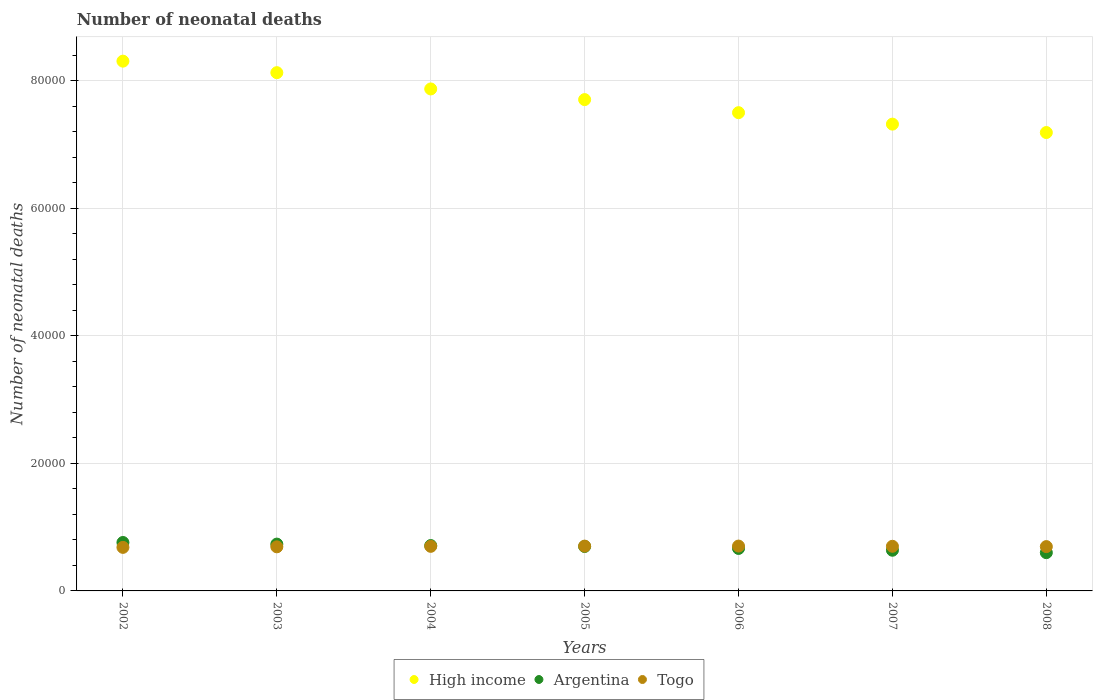How many different coloured dotlines are there?
Provide a succinct answer. 3. What is the number of neonatal deaths in in Togo in 2007?
Offer a very short reply. 6999. Across all years, what is the maximum number of neonatal deaths in in Togo?
Your response must be concise. 7032. Across all years, what is the minimum number of neonatal deaths in in Togo?
Your answer should be compact. 6828. What is the total number of neonatal deaths in in Argentina in the graph?
Give a very brief answer. 4.81e+04. What is the difference between the number of neonatal deaths in in Argentina in 2003 and that in 2007?
Offer a very short reply. 962. What is the difference between the number of neonatal deaths in in Togo in 2006 and the number of neonatal deaths in in High income in 2004?
Keep it short and to the point. -7.17e+04. What is the average number of neonatal deaths in in Togo per year?
Provide a short and direct response. 6962.57. In the year 2005, what is the difference between the number of neonatal deaths in in Argentina and number of neonatal deaths in in Togo?
Keep it short and to the point. -61. What is the ratio of the number of neonatal deaths in in High income in 2002 to that in 2006?
Provide a short and direct response. 1.11. What is the difference between the highest and the second highest number of neonatal deaths in in High income?
Your answer should be very brief. 1805. What is the difference between the highest and the lowest number of neonatal deaths in in Togo?
Ensure brevity in your answer.  204. In how many years, is the number of neonatal deaths in in Togo greater than the average number of neonatal deaths in in Togo taken over all years?
Provide a succinct answer. 4. Is it the case that in every year, the sum of the number of neonatal deaths in in Togo and number of neonatal deaths in in High income  is greater than the number of neonatal deaths in in Argentina?
Your response must be concise. Yes. Does the number of neonatal deaths in in Togo monotonically increase over the years?
Your answer should be very brief. No. How many dotlines are there?
Provide a short and direct response. 3. Does the graph contain grids?
Give a very brief answer. Yes. How many legend labels are there?
Provide a succinct answer. 3. What is the title of the graph?
Ensure brevity in your answer.  Number of neonatal deaths. Does "East Asia (all income levels)" appear as one of the legend labels in the graph?
Provide a short and direct response. No. What is the label or title of the Y-axis?
Your response must be concise. Number of neonatal deaths. What is the Number of neonatal deaths in High income in 2002?
Your answer should be very brief. 8.31e+04. What is the Number of neonatal deaths in Argentina in 2002?
Your response must be concise. 7595. What is the Number of neonatal deaths in Togo in 2002?
Provide a short and direct response. 6828. What is the Number of neonatal deaths in High income in 2003?
Offer a very short reply. 8.13e+04. What is the Number of neonatal deaths of Argentina in 2003?
Make the answer very short. 7341. What is the Number of neonatal deaths in Togo in 2003?
Your response must be concise. 6914. What is the Number of neonatal deaths in High income in 2004?
Your answer should be compact. 7.87e+04. What is the Number of neonatal deaths in Argentina in 2004?
Keep it short and to the point. 7113. What is the Number of neonatal deaths in Togo in 2004?
Your answer should be compact. 6990. What is the Number of neonatal deaths in High income in 2005?
Make the answer very short. 7.70e+04. What is the Number of neonatal deaths of Argentina in 2005?
Provide a succinct answer. 6965. What is the Number of neonatal deaths in Togo in 2005?
Keep it short and to the point. 7026. What is the Number of neonatal deaths of High income in 2006?
Offer a terse response. 7.50e+04. What is the Number of neonatal deaths of Argentina in 2006?
Offer a very short reply. 6660. What is the Number of neonatal deaths in Togo in 2006?
Make the answer very short. 7032. What is the Number of neonatal deaths in High income in 2007?
Your answer should be compact. 7.32e+04. What is the Number of neonatal deaths in Argentina in 2007?
Your answer should be very brief. 6379. What is the Number of neonatal deaths of Togo in 2007?
Ensure brevity in your answer.  6999. What is the Number of neonatal deaths in High income in 2008?
Provide a short and direct response. 7.19e+04. What is the Number of neonatal deaths in Argentina in 2008?
Keep it short and to the point. 6001. What is the Number of neonatal deaths of Togo in 2008?
Your answer should be compact. 6949. Across all years, what is the maximum Number of neonatal deaths of High income?
Your answer should be very brief. 8.31e+04. Across all years, what is the maximum Number of neonatal deaths of Argentina?
Provide a succinct answer. 7595. Across all years, what is the maximum Number of neonatal deaths of Togo?
Your answer should be compact. 7032. Across all years, what is the minimum Number of neonatal deaths of High income?
Offer a terse response. 7.19e+04. Across all years, what is the minimum Number of neonatal deaths in Argentina?
Provide a succinct answer. 6001. Across all years, what is the minimum Number of neonatal deaths in Togo?
Ensure brevity in your answer.  6828. What is the total Number of neonatal deaths of High income in the graph?
Keep it short and to the point. 5.40e+05. What is the total Number of neonatal deaths of Argentina in the graph?
Your response must be concise. 4.81e+04. What is the total Number of neonatal deaths of Togo in the graph?
Provide a succinct answer. 4.87e+04. What is the difference between the Number of neonatal deaths in High income in 2002 and that in 2003?
Ensure brevity in your answer.  1805. What is the difference between the Number of neonatal deaths in Argentina in 2002 and that in 2003?
Make the answer very short. 254. What is the difference between the Number of neonatal deaths in Togo in 2002 and that in 2003?
Provide a succinct answer. -86. What is the difference between the Number of neonatal deaths of High income in 2002 and that in 2004?
Keep it short and to the point. 4358. What is the difference between the Number of neonatal deaths of Argentina in 2002 and that in 2004?
Offer a very short reply. 482. What is the difference between the Number of neonatal deaths in Togo in 2002 and that in 2004?
Offer a very short reply. -162. What is the difference between the Number of neonatal deaths in High income in 2002 and that in 2005?
Provide a succinct answer. 6029. What is the difference between the Number of neonatal deaths in Argentina in 2002 and that in 2005?
Your response must be concise. 630. What is the difference between the Number of neonatal deaths of Togo in 2002 and that in 2005?
Make the answer very short. -198. What is the difference between the Number of neonatal deaths of High income in 2002 and that in 2006?
Offer a very short reply. 8079. What is the difference between the Number of neonatal deaths in Argentina in 2002 and that in 2006?
Provide a succinct answer. 935. What is the difference between the Number of neonatal deaths in Togo in 2002 and that in 2006?
Your answer should be compact. -204. What is the difference between the Number of neonatal deaths in High income in 2002 and that in 2007?
Provide a succinct answer. 9875. What is the difference between the Number of neonatal deaths in Argentina in 2002 and that in 2007?
Offer a terse response. 1216. What is the difference between the Number of neonatal deaths in Togo in 2002 and that in 2007?
Your answer should be very brief. -171. What is the difference between the Number of neonatal deaths of High income in 2002 and that in 2008?
Your answer should be very brief. 1.12e+04. What is the difference between the Number of neonatal deaths in Argentina in 2002 and that in 2008?
Offer a very short reply. 1594. What is the difference between the Number of neonatal deaths of Togo in 2002 and that in 2008?
Keep it short and to the point. -121. What is the difference between the Number of neonatal deaths of High income in 2003 and that in 2004?
Offer a very short reply. 2553. What is the difference between the Number of neonatal deaths in Argentina in 2003 and that in 2004?
Your response must be concise. 228. What is the difference between the Number of neonatal deaths of Togo in 2003 and that in 2004?
Provide a short and direct response. -76. What is the difference between the Number of neonatal deaths in High income in 2003 and that in 2005?
Offer a terse response. 4224. What is the difference between the Number of neonatal deaths in Argentina in 2003 and that in 2005?
Ensure brevity in your answer.  376. What is the difference between the Number of neonatal deaths in Togo in 2003 and that in 2005?
Your answer should be very brief. -112. What is the difference between the Number of neonatal deaths of High income in 2003 and that in 2006?
Provide a succinct answer. 6274. What is the difference between the Number of neonatal deaths in Argentina in 2003 and that in 2006?
Your answer should be very brief. 681. What is the difference between the Number of neonatal deaths of Togo in 2003 and that in 2006?
Offer a very short reply. -118. What is the difference between the Number of neonatal deaths of High income in 2003 and that in 2007?
Provide a succinct answer. 8070. What is the difference between the Number of neonatal deaths in Argentina in 2003 and that in 2007?
Ensure brevity in your answer.  962. What is the difference between the Number of neonatal deaths in Togo in 2003 and that in 2007?
Provide a succinct answer. -85. What is the difference between the Number of neonatal deaths of High income in 2003 and that in 2008?
Provide a short and direct response. 9390. What is the difference between the Number of neonatal deaths of Argentina in 2003 and that in 2008?
Keep it short and to the point. 1340. What is the difference between the Number of neonatal deaths in Togo in 2003 and that in 2008?
Ensure brevity in your answer.  -35. What is the difference between the Number of neonatal deaths of High income in 2004 and that in 2005?
Your response must be concise. 1671. What is the difference between the Number of neonatal deaths in Argentina in 2004 and that in 2005?
Give a very brief answer. 148. What is the difference between the Number of neonatal deaths in Togo in 2004 and that in 2005?
Offer a very short reply. -36. What is the difference between the Number of neonatal deaths in High income in 2004 and that in 2006?
Provide a succinct answer. 3721. What is the difference between the Number of neonatal deaths of Argentina in 2004 and that in 2006?
Offer a terse response. 453. What is the difference between the Number of neonatal deaths of Togo in 2004 and that in 2006?
Offer a terse response. -42. What is the difference between the Number of neonatal deaths of High income in 2004 and that in 2007?
Give a very brief answer. 5517. What is the difference between the Number of neonatal deaths of Argentina in 2004 and that in 2007?
Give a very brief answer. 734. What is the difference between the Number of neonatal deaths of High income in 2004 and that in 2008?
Ensure brevity in your answer.  6837. What is the difference between the Number of neonatal deaths of Argentina in 2004 and that in 2008?
Provide a succinct answer. 1112. What is the difference between the Number of neonatal deaths in Togo in 2004 and that in 2008?
Keep it short and to the point. 41. What is the difference between the Number of neonatal deaths in High income in 2005 and that in 2006?
Make the answer very short. 2050. What is the difference between the Number of neonatal deaths of Argentina in 2005 and that in 2006?
Offer a terse response. 305. What is the difference between the Number of neonatal deaths of High income in 2005 and that in 2007?
Provide a succinct answer. 3846. What is the difference between the Number of neonatal deaths in Argentina in 2005 and that in 2007?
Your response must be concise. 586. What is the difference between the Number of neonatal deaths in High income in 2005 and that in 2008?
Your answer should be compact. 5166. What is the difference between the Number of neonatal deaths in Argentina in 2005 and that in 2008?
Offer a very short reply. 964. What is the difference between the Number of neonatal deaths in Togo in 2005 and that in 2008?
Give a very brief answer. 77. What is the difference between the Number of neonatal deaths in High income in 2006 and that in 2007?
Your answer should be very brief. 1796. What is the difference between the Number of neonatal deaths of Argentina in 2006 and that in 2007?
Your answer should be very brief. 281. What is the difference between the Number of neonatal deaths in High income in 2006 and that in 2008?
Keep it short and to the point. 3116. What is the difference between the Number of neonatal deaths of Argentina in 2006 and that in 2008?
Keep it short and to the point. 659. What is the difference between the Number of neonatal deaths of Togo in 2006 and that in 2008?
Keep it short and to the point. 83. What is the difference between the Number of neonatal deaths in High income in 2007 and that in 2008?
Your answer should be compact. 1320. What is the difference between the Number of neonatal deaths of Argentina in 2007 and that in 2008?
Your answer should be very brief. 378. What is the difference between the Number of neonatal deaths in High income in 2002 and the Number of neonatal deaths in Argentina in 2003?
Your answer should be very brief. 7.57e+04. What is the difference between the Number of neonatal deaths in High income in 2002 and the Number of neonatal deaths in Togo in 2003?
Your answer should be compact. 7.62e+04. What is the difference between the Number of neonatal deaths of Argentina in 2002 and the Number of neonatal deaths of Togo in 2003?
Offer a terse response. 681. What is the difference between the Number of neonatal deaths in High income in 2002 and the Number of neonatal deaths in Argentina in 2004?
Provide a succinct answer. 7.60e+04. What is the difference between the Number of neonatal deaths of High income in 2002 and the Number of neonatal deaths of Togo in 2004?
Give a very brief answer. 7.61e+04. What is the difference between the Number of neonatal deaths of Argentina in 2002 and the Number of neonatal deaths of Togo in 2004?
Your answer should be very brief. 605. What is the difference between the Number of neonatal deaths in High income in 2002 and the Number of neonatal deaths in Argentina in 2005?
Keep it short and to the point. 7.61e+04. What is the difference between the Number of neonatal deaths in High income in 2002 and the Number of neonatal deaths in Togo in 2005?
Your answer should be compact. 7.60e+04. What is the difference between the Number of neonatal deaths of Argentina in 2002 and the Number of neonatal deaths of Togo in 2005?
Your answer should be compact. 569. What is the difference between the Number of neonatal deaths in High income in 2002 and the Number of neonatal deaths in Argentina in 2006?
Keep it short and to the point. 7.64e+04. What is the difference between the Number of neonatal deaths in High income in 2002 and the Number of neonatal deaths in Togo in 2006?
Your answer should be compact. 7.60e+04. What is the difference between the Number of neonatal deaths of Argentina in 2002 and the Number of neonatal deaths of Togo in 2006?
Keep it short and to the point. 563. What is the difference between the Number of neonatal deaths of High income in 2002 and the Number of neonatal deaths of Argentina in 2007?
Your response must be concise. 7.67e+04. What is the difference between the Number of neonatal deaths of High income in 2002 and the Number of neonatal deaths of Togo in 2007?
Offer a very short reply. 7.61e+04. What is the difference between the Number of neonatal deaths of Argentina in 2002 and the Number of neonatal deaths of Togo in 2007?
Provide a succinct answer. 596. What is the difference between the Number of neonatal deaths of High income in 2002 and the Number of neonatal deaths of Argentina in 2008?
Offer a very short reply. 7.71e+04. What is the difference between the Number of neonatal deaths in High income in 2002 and the Number of neonatal deaths in Togo in 2008?
Offer a terse response. 7.61e+04. What is the difference between the Number of neonatal deaths in Argentina in 2002 and the Number of neonatal deaths in Togo in 2008?
Your answer should be compact. 646. What is the difference between the Number of neonatal deaths of High income in 2003 and the Number of neonatal deaths of Argentina in 2004?
Keep it short and to the point. 7.42e+04. What is the difference between the Number of neonatal deaths of High income in 2003 and the Number of neonatal deaths of Togo in 2004?
Provide a short and direct response. 7.43e+04. What is the difference between the Number of neonatal deaths of Argentina in 2003 and the Number of neonatal deaths of Togo in 2004?
Your response must be concise. 351. What is the difference between the Number of neonatal deaths in High income in 2003 and the Number of neonatal deaths in Argentina in 2005?
Offer a very short reply. 7.43e+04. What is the difference between the Number of neonatal deaths in High income in 2003 and the Number of neonatal deaths in Togo in 2005?
Make the answer very short. 7.42e+04. What is the difference between the Number of neonatal deaths in Argentina in 2003 and the Number of neonatal deaths in Togo in 2005?
Make the answer very short. 315. What is the difference between the Number of neonatal deaths in High income in 2003 and the Number of neonatal deaths in Argentina in 2006?
Give a very brief answer. 7.46e+04. What is the difference between the Number of neonatal deaths of High income in 2003 and the Number of neonatal deaths of Togo in 2006?
Offer a terse response. 7.42e+04. What is the difference between the Number of neonatal deaths in Argentina in 2003 and the Number of neonatal deaths in Togo in 2006?
Provide a short and direct response. 309. What is the difference between the Number of neonatal deaths of High income in 2003 and the Number of neonatal deaths of Argentina in 2007?
Give a very brief answer. 7.49e+04. What is the difference between the Number of neonatal deaths of High income in 2003 and the Number of neonatal deaths of Togo in 2007?
Provide a short and direct response. 7.43e+04. What is the difference between the Number of neonatal deaths in Argentina in 2003 and the Number of neonatal deaths in Togo in 2007?
Your answer should be compact. 342. What is the difference between the Number of neonatal deaths in High income in 2003 and the Number of neonatal deaths in Argentina in 2008?
Your answer should be very brief. 7.53e+04. What is the difference between the Number of neonatal deaths in High income in 2003 and the Number of neonatal deaths in Togo in 2008?
Give a very brief answer. 7.43e+04. What is the difference between the Number of neonatal deaths of Argentina in 2003 and the Number of neonatal deaths of Togo in 2008?
Your answer should be very brief. 392. What is the difference between the Number of neonatal deaths in High income in 2004 and the Number of neonatal deaths in Argentina in 2005?
Provide a short and direct response. 7.17e+04. What is the difference between the Number of neonatal deaths in High income in 2004 and the Number of neonatal deaths in Togo in 2005?
Make the answer very short. 7.17e+04. What is the difference between the Number of neonatal deaths in High income in 2004 and the Number of neonatal deaths in Argentina in 2006?
Give a very brief answer. 7.20e+04. What is the difference between the Number of neonatal deaths of High income in 2004 and the Number of neonatal deaths of Togo in 2006?
Your answer should be very brief. 7.17e+04. What is the difference between the Number of neonatal deaths of High income in 2004 and the Number of neonatal deaths of Argentina in 2007?
Offer a terse response. 7.23e+04. What is the difference between the Number of neonatal deaths in High income in 2004 and the Number of neonatal deaths in Togo in 2007?
Ensure brevity in your answer.  7.17e+04. What is the difference between the Number of neonatal deaths of Argentina in 2004 and the Number of neonatal deaths of Togo in 2007?
Provide a short and direct response. 114. What is the difference between the Number of neonatal deaths in High income in 2004 and the Number of neonatal deaths in Argentina in 2008?
Offer a terse response. 7.27e+04. What is the difference between the Number of neonatal deaths in High income in 2004 and the Number of neonatal deaths in Togo in 2008?
Offer a terse response. 7.18e+04. What is the difference between the Number of neonatal deaths in Argentina in 2004 and the Number of neonatal deaths in Togo in 2008?
Provide a short and direct response. 164. What is the difference between the Number of neonatal deaths in High income in 2005 and the Number of neonatal deaths in Argentina in 2006?
Give a very brief answer. 7.04e+04. What is the difference between the Number of neonatal deaths in High income in 2005 and the Number of neonatal deaths in Togo in 2006?
Give a very brief answer. 7.00e+04. What is the difference between the Number of neonatal deaths of Argentina in 2005 and the Number of neonatal deaths of Togo in 2006?
Your response must be concise. -67. What is the difference between the Number of neonatal deaths in High income in 2005 and the Number of neonatal deaths in Argentina in 2007?
Offer a very short reply. 7.07e+04. What is the difference between the Number of neonatal deaths of High income in 2005 and the Number of neonatal deaths of Togo in 2007?
Give a very brief answer. 7.00e+04. What is the difference between the Number of neonatal deaths of Argentina in 2005 and the Number of neonatal deaths of Togo in 2007?
Provide a short and direct response. -34. What is the difference between the Number of neonatal deaths of High income in 2005 and the Number of neonatal deaths of Argentina in 2008?
Your response must be concise. 7.10e+04. What is the difference between the Number of neonatal deaths of High income in 2005 and the Number of neonatal deaths of Togo in 2008?
Make the answer very short. 7.01e+04. What is the difference between the Number of neonatal deaths in Argentina in 2005 and the Number of neonatal deaths in Togo in 2008?
Offer a very short reply. 16. What is the difference between the Number of neonatal deaths of High income in 2006 and the Number of neonatal deaths of Argentina in 2007?
Provide a succinct answer. 6.86e+04. What is the difference between the Number of neonatal deaths in High income in 2006 and the Number of neonatal deaths in Togo in 2007?
Provide a short and direct response. 6.80e+04. What is the difference between the Number of neonatal deaths of Argentina in 2006 and the Number of neonatal deaths of Togo in 2007?
Keep it short and to the point. -339. What is the difference between the Number of neonatal deaths of High income in 2006 and the Number of neonatal deaths of Argentina in 2008?
Keep it short and to the point. 6.90e+04. What is the difference between the Number of neonatal deaths of High income in 2006 and the Number of neonatal deaths of Togo in 2008?
Provide a short and direct response. 6.80e+04. What is the difference between the Number of neonatal deaths of Argentina in 2006 and the Number of neonatal deaths of Togo in 2008?
Give a very brief answer. -289. What is the difference between the Number of neonatal deaths in High income in 2007 and the Number of neonatal deaths in Argentina in 2008?
Give a very brief answer. 6.72e+04. What is the difference between the Number of neonatal deaths of High income in 2007 and the Number of neonatal deaths of Togo in 2008?
Your answer should be compact. 6.62e+04. What is the difference between the Number of neonatal deaths in Argentina in 2007 and the Number of neonatal deaths in Togo in 2008?
Your answer should be very brief. -570. What is the average Number of neonatal deaths in High income per year?
Your response must be concise. 7.72e+04. What is the average Number of neonatal deaths in Argentina per year?
Offer a very short reply. 6864.86. What is the average Number of neonatal deaths in Togo per year?
Your answer should be compact. 6962.57. In the year 2002, what is the difference between the Number of neonatal deaths of High income and Number of neonatal deaths of Argentina?
Keep it short and to the point. 7.55e+04. In the year 2002, what is the difference between the Number of neonatal deaths in High income and Number of neonatal deaths in Togo?
Provide a short and direct response. 7.62e+04. In the year 2002, what is the difference between the Number of neonatal deaths of Argentina and Number of neonatal deaths of Togo?
Keep it short and to the point. 767. In the year 2003, what is the difference between the Number of neonatal deaths of High income and Number of neonatal deaths of Argentina?
Ensure brevity in your answer.  7.39e+04. In the year 2003, what is the difference between the Number of neonatal deaths in High income and Number of neonatal deaths in Togo?
Ensure brevity in your answer.  7.43e+04. In the year 2003, what is the difference between the Number of neonatal deaths of Argentina and Number of neonatal deaths of Togo?
Ensure brevity in your answer.  427. In the year 2004, what is the difference between the Number of neonatal deaths of High income and Number of neonatal deaths of Argentina?
Provide a short and direct response. 7.16e+04. In the year 2004, what is the difference between the Number of neonatal deaths of High income and Number of neonatal deaths of Togo?
Make the answer very short. 7.17e+04. In the year 2004, what is the difference between the Number of neonatal deaths of Argentina and Number of neonatal deaths of Togo?
Your answer should be compact. 123. In the year 2005, what is the difference between the Number of neonatal deaths of High income and Number of neonatal deaths of Argentina?
Your answer should be very brief. 7.01e+04. In the year 2005, what is the difference between the Number of neonatal deaths in High income and Number of neonatal deaths in Togo?
Your answer should be compact. 7.00e+04. In the year 2005, what is the difference between the Number of neonatal deaths of Argentina and Number of neonatal deaths of Togo?
Offer a terse response. -61. In the year 2006, what is the difference between the Number of neonatal deaths in High income and Number of neonatal deaths in Argentina?
Provide a short and direct response. 6.83e+04. In the year 2006, what is the difference between the Number of neonatal deaths of High income and Number of neonatal deaths of Togo?
Your answer should be very brief. 6.80e+04. In the year 2006, what is the difference between the Number of neonatal deaths of Argentina and Number of neonatal deaths of Togo?
Provide a succinct answer. -372. In the year 2007, what is the difference between the Number of neonatal deaths of High income and Number of neonatal deaths of Argentina?
Provide a succinct answer. 6.68e+04. In the year 2007, what is the difference between the Number of neonatal deaths of High income and Number of neonatal deaths of Togo?
Give a very brief answer. 6.62e+04. In the year 2007, what is the difference between the Number of neonatal deaths in Argentina and Number of neonatal deaths in Togo?
Offer a very short reply. -620. In the year 2008, what is the difference between the Number of neonatal deaths of High income and Number of neonatal deaths of Argentina?
Keep it short and to the point. 6.59e+04. In the year 2008, what is the difference between the Number of neonatal deaths of High income and Number of neonatal deaths of Togo?
Provide a succinct answer. 6.49e+04. In the year 2008, what is the difference between the Number of neonatal deaths in Argentina and Number of neonatal deaths in Togo?
Give a very brief answer. -948. What is the ratio of the Number of neonatal deaths in High income in 2002 to that in 2003?
Provide a succinct answer. 1.02. What is the ratio of the Number of neonatal deaths of Argentina in 2002 to that in 2003?
Ensure brevity in your answer.  1.03. What is the ratio of the Number of neonatal deaths of Togo in 2002 to that in 2003?
Give a very brief answer. 0.99. What is the ratio of the Number of neonatal deaths in High income in 2002 to that in 2004?
Your answer should be very brief. 1.06. What is the ratio of the Number of neonatal deaths in Argentina in 2002 to that in 2004?
Offer a terse response. 1.07. What is the ratio of the Number of neonatal deaths of Togo in 2002 to that in 2004?
Offer a terse response. 0.98. What is the ratio of the Number of neonatal deaths of High income in 2002 to that in 2005?
Keep it short and to the point. 1.08. What is the ratio of the Number of neonatal deaths in Argentina in 2002 to that in 2005?
Offer a terse response. 1.09. What is the ratio of the Number of neonatal deaths of Togo in 2002 to that in 2005?
Offer a terse response. 0.97. What is the ratio of the Number of neonatal deaths of High income in 2002 to that in 2006?
Provide a succinct answer. 1.11. What is the ratio of the Number of neonatal deaths in Argentina in 2002 to that in 2006?
Your answer should be compact. 1.14. What is the ratio of the Number of neonatal deaths of High income in 2002 to that in 2007?
Provide a succinct answer. 1.13. What is the ratio of the Number of neonatal deaths in Argentina in 2002 to that in 2007?
Make the answer very short. 1.19. What is the ratio of the Number of neonatal deaths of Togo in 2002 to that in 2007?
Provide a succinct answer. 0.98. What is the ratio of the Number of neonatal deaths of High income in 2002 to that in 2008?
Provide a short and direct response. 1.16. What is the ratio of the Number of neonatal deaths in Argentina in 2002 to that in 2008?
Your response must be concise. 1.27. What is the ratio of the Number of neonatal deaths of Togo in 2002 to that in 2008?
Ensure brevity in your answer.  0.98. What is the ratio of the Number of neonatal deaths of High income in 2003 to that in 2004?
Ensure brevity in your answer.  1.03. What is the ratio of the Number of neonatal deaths of Argentina in 2003 to that in 2004?
Offer a terse response. 1.03. What is the ratio of the Number of neonatal deaths in Togo in 2003 to that in 2004?
Provide a short and direct response. 0.99. What is the ratio of the Number of neonatal deaths of High income in 2003 to that in 2005?
Offer a very short reply. 1.05. What is the ratio of the Number of neonatal deaths of Argentina in 2003 to that in 2005?
Make the answer very short. 1.05. What is the ratio of the Number of neonatal deaths of Togo in 2003 to that in 2005?
Keep it short and to the point. 0.98. What is the ratio of the Number of neonatal deaths of High income in 2003 to that in 2006?
Make the answer very short. 1.08. What is the ratio of the Number of neonatal deaths of Argentina in 2003 to that in 2006?
Provide a succinct answer. 1.1. What is the ratio of the Number of neonatal deaths of Togo in 2003 to that in 2006?
Give a very brief answer. 0.98. What is the ratio of the Number of neonatal deaths of High income in 2003 to that in 2007?
Offer a very short reply. 1.11. What is the ratio of the Number of neonatal deaths in Argentina in 2003 to that in 2007?
Make the answer very short. 1.15. What is the ratio of the Number of neonatal deaths in Togo in 2003 to that in 2007?
Give a very brief answer. 0.99. What is the ratio of the Number of neonatal deaths of High income in 2003 to that in 2008?
Make the answer very short. 1.13. What is the ratio of the Number of neonatal deaths in Argentina in 2003 to that in 2008?
Your answer should be compact. 1.22. What is the ratio of the Number of neonatal deaths in Togo in 2003 to that in 2008?
Make the answer very short. 0.99. What is the ratio of the Number of neonatal deaths in High income in 2004 to that in 2005?
Give a very brief answer. 1.02. What is the ratio of the Number of neonatal deaths in Argentina in 2004 to that in 2005?
Give a very brief answer. 1.02. What is the ratio of the Number of neonatal deaths of Togo in 2004 to that in 2005?
Make the answer very short. 0.99. What is the ratio of the Number of neonatal deaths of High income in 2004 to that in 2006?
Keep it short and to the point. 1.05. What is the ratio of the Number of neonatal deaths in Argentina in 2004 to that in 2006?
Keep it short and to the point. 1.07. What is the ratio of the Number of neonatal deaths in Togo in 2004 to that in 2006?
Your answer should be compact. 0.99. What is the ratio of the Number of neonatal deaths of High income in 2004 to that in 2007?
Offer a terse response. 1.08. What is the ratio of the Number of neonatal deaths in Argentina in 2004 to that in 2007?
Your answer should be compact. 1.12. What is the ratio of the Number of neonatal deaths of High income in 2004 to that in 2008?
Make the answer very short. 1.1. What is the ratio of the Number of neonatal deaths in Argentina in 2004 to that in 2008?
Offer a terse response. 1.19. What is the ratio of the Number of neonatal deaths of Togo in 2004 to that in 2008?
Provide a succinct answer. 1.01. What is the ratio of the Number of neonatal deaths in High income in 2005 to that in 2006?
Give a very brief answer. 1.03. What is the ratio of the Number of neonatal deaths in Argentina in 2005 to that in 2006?
Provide a short and direct response. 1.05. What is the ratio of the Number of neonatal deaths of Togo in 2005 to that in 2006?
Your answer should be compact. 1. What is the ratio of the Number of neonatal deaths of High income in 2005 to that in 2007?
Your answer should be compact. 1.05. What is the ratio of the Number of neonatal deaths in Argentina in 2005 to that in 2007?
Offer a very short reply. 1.09. What is the ratio of the Number of neonatal deaths in High income in 2005 to that in 2008?
Provide a succinct answer. 1.07. What is the ratio of the Number of neonatal deaths in Argentina in 2005 to that in 2008?
Your answer should be compact. 1.16. What is the ratio of the Number of neonatal deaths of Togo in 2005 to that in 2008?
Make the answer very short. 1.01. What is the ratio of the Number of neonatal deaths in High income in 2006 to that in 2007?
Provide a short and direct response. 1.02. What is the ratio of the Number of neonatal deaths in Argentina in 2006 to that in 2007?
Keep it short and to the point. 1.04. What is the ratio of the Number of neonatal deaths of Togo in 2006 to that in 2007?
Keep it short and to the point. 1. What is the ratio of the Number of neonatal deaths in High income in 2006 to that in 2008?
Your answer should be very brief. 1.04. What is the ratio of the Number of neonatal deaths of Argentina in 2006 to that in 2008?
Give a very brief answer. 1.11. What is the ratio of the Number of neonatal deaths of Togo in 2006 to that in 2008?
Offer a very short reply. 1.01. What is the ratio of the Number of neonatal deaths in High income in 2007 to that in 2008?
Keep it short and to the point. 1.02. What is the ratio of the Number of neonatal deaths in Argentina in 2007 to that in 2008?
Provide a succinct answer. 1.06. What is the ratio of the Number of neonatal deaths in Togo in 2007 to that in 2008?
Offer a terse response. 1.01. What is the difference between the highest and the second highest Number of neonatal deaths of High income?
Make the answer very short. 1805. What is the difference between the highest and the second highest Number of neonatal deaths in Argentina?
Provide a succinct answer. 254. What is the difference between the highest and the second highest Number of neonatal deaths of Togo?
Provide a succinct answer. 6. What is the difference between the highest and the lowest Number of neonatal deaths of High income?
Your answer should be compact. 1.12e+04. What is the difference between the highest and the lowest Number of neonatal deaths of Argentina?
Your response must be concise. 1594. What is the difference between the highest and the lowest Number of neonatal deaths of Togo?
Your response must be concise. 204. 